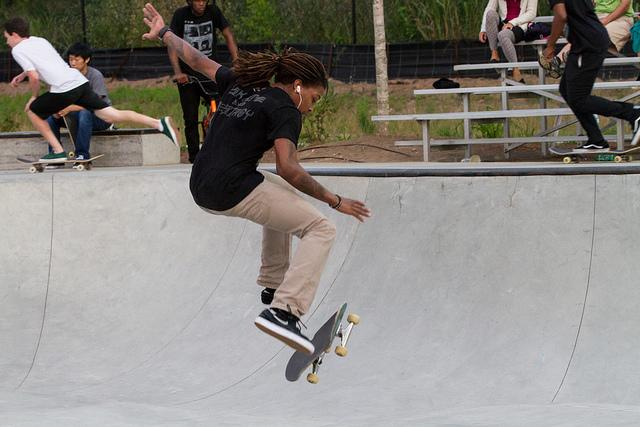What's the name of this type of skating area?

Choices:
A) pipe
B) grid
C) ramp
D) bowl bowl 